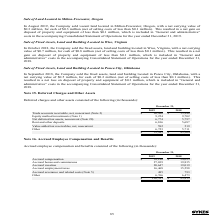According to Sykes Enterprises Incorporated's financial document, What was the amount of Accrued severance and related costs in 2019? According to the financial document, 485 (in thousands). The relevant text states: "Accrued severance and related costs (Note 5) 485 793..." Also, What was the amount of  Accrued employment taxes  in 2018? According to the financial document, 15,598 (in thousands). The relevant text states: "Accrued employment taxes 16,468 15,598..." Also, In which years were the Accrued employee compensation and benefits calculated? The document shows two values: 2019 and 2018. From the document: "2019 2018 2019 2018..." Additionally, In which year was the amount of Other larger? According to the financial document, 2019. The relevant text states: "2019 2018..." Also, can you calculate: What was the change in Accrued severance and related costs in 2019 from 2018? Based on the calculation: 485-793, the result is -308 (in thousands). This is based on the information: "Accrued severance and related costs (Note 5) 485 793 Accrued severance and related costs (Note 5) 485 793..." The key data points involved are: 485, 793. Also, can you calculate: What was the percentage change in Accrued severance and related costs in 2019 from 2018? To answer this question, I need to perform calculations using the financial data. The calculation is: (485-793)/793, which equals -38.84 (percentage). This is based on the information: "Accrued severance and related costs (Note 5) 485 793 Accrued severance and related costs (Note 5) 485 793..." The key data points involved are: 485, 793. 